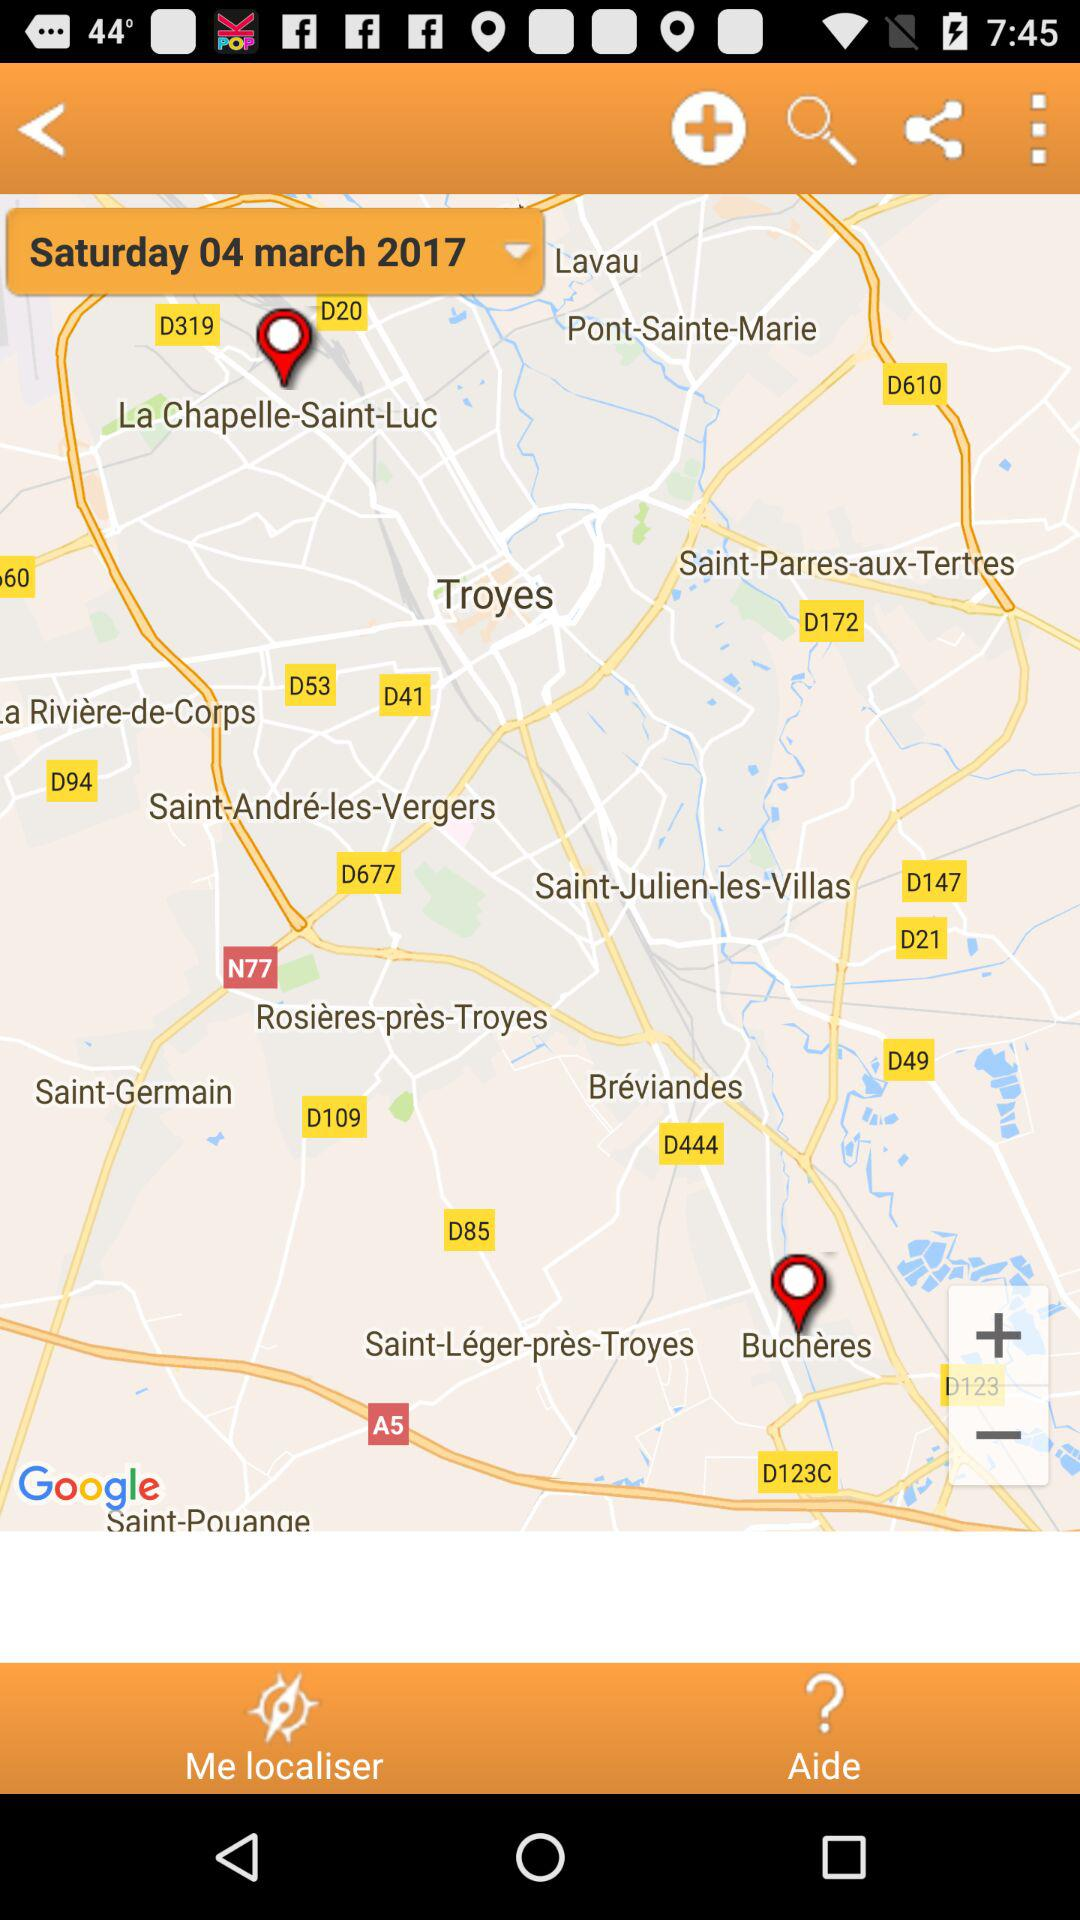What is the date displayed on the screen? The date displayed is Saturday, March 04, 2017. 